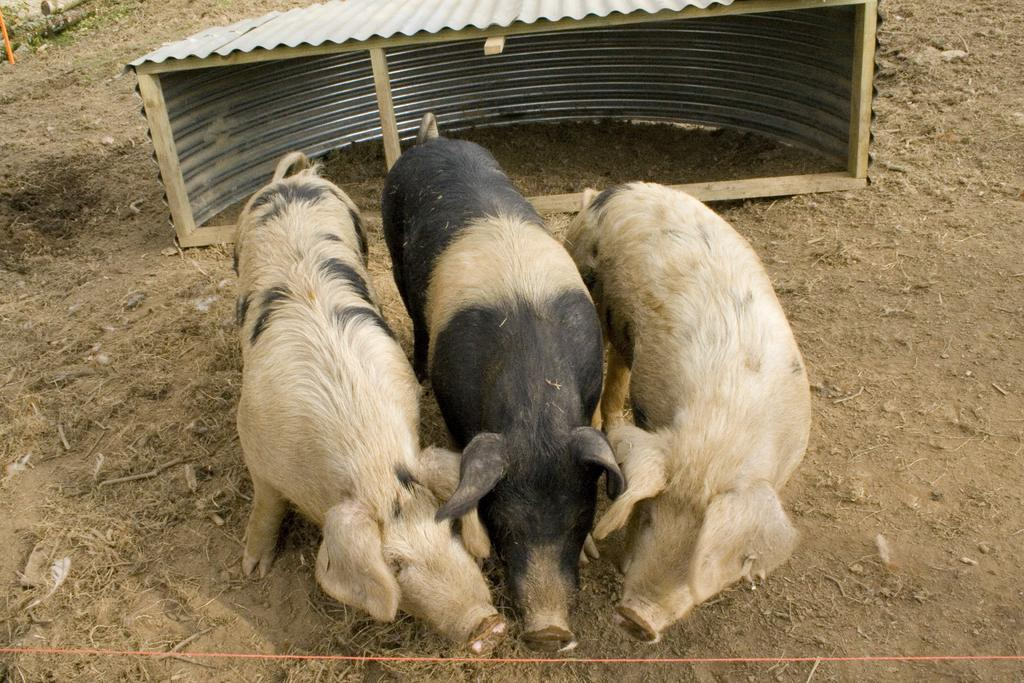What is located in the center of the image? There are three animals in the center of the image. What can be seen in the background of the image? There is a small shed in the background of the image. What type of terrain is at the bottom of the image? There is sand at the bottom of the image. What type of vegetation is present in the image? There is dry grass in the image. How many bubbles are floating around the animals in the image? There are no bubbles present in the image; it features three animals, a small shed, sand, and dry grass. 